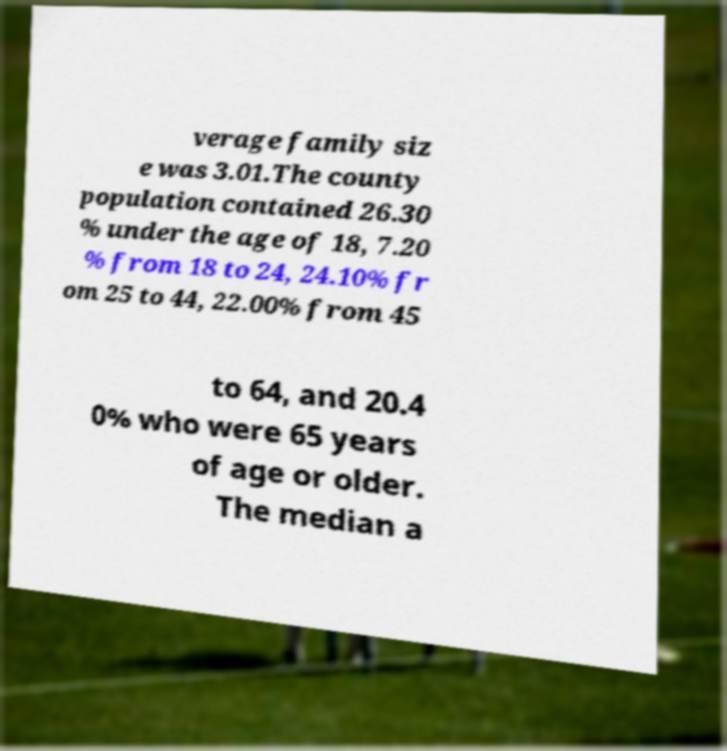There's text embedded in this image that I need extracted. Can you transcribe it verbatim? verage family siz e was 3.01.The county population contained 26.30 % under the age of 18, 7.20 % from 18 to 24, 24.10% fr om 25 to 44, 22.00% from 45 to 64, and 20.4 0% who were 65 years of age or older. The median a 